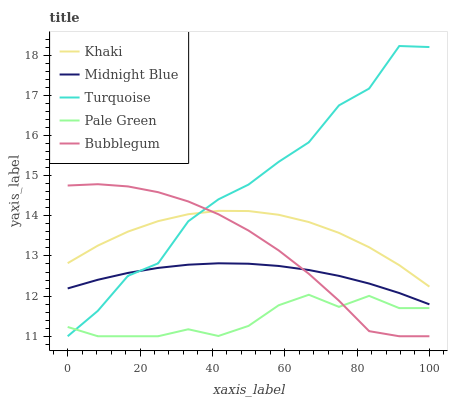Does Pale Green have the minimum area under the curve?
Answer yes or no. Yes. Does Turquoise have the maximum area under the curve?
Answer yes or no. Yes. Does Khaki have the minimum area under the curve?
Answer yes or no. No. Does Khaki have the maximum area under the curve?
Answer yes or no. No. Is Midnight Blue the smoothest?
Answer yes or no. Yes. Is Turquoise the roughest?
Answer yes or no. Yes. Is Khaki the smoothest?
Answer yes or no. No. Is Khaki the roughest?
Answer yes or no. No. Does Pale Green have the lowest value?
Answer yes or no. Yes. Does Khaki have the lowest value?
Answer yes or no. No. Does Turquoise have the highest value?
Answer yes or no. Yes. Does Khaki have the highest value?
Answer yes or no. No. Is Pale Green less than Midnight Blue?
Answer yes or no. Yes. Is Midnight Blue greater than Pale Green?
Answer yes or no. Yes. Does Turquoise intersect Bubblegum?
Answer yes or no. Yes. Is Turquoise less than Bubblegum?
Answer yes or no. No. Is Turquoise greater than Bubblegum?
Answer yes or no. No. Does Pale Green intersect Midnight Blue?
Answer yes or no. No. 